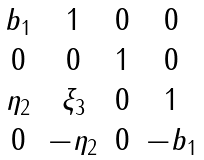Convert formula to latex. <formula><loc_0><loc_0><loc_500><loc_500>\begin{matrix} b _ { 1 } & 1 & 0 & 0 \\ 0 & 0 & 1 & 0 \\ \eta _ { 2 } & \xi _ { 3 } & 0 & 1 \\ 0 & - \eta _ { 2 } & 0 & - b _ { 1 } \end{matrix}</formula> 